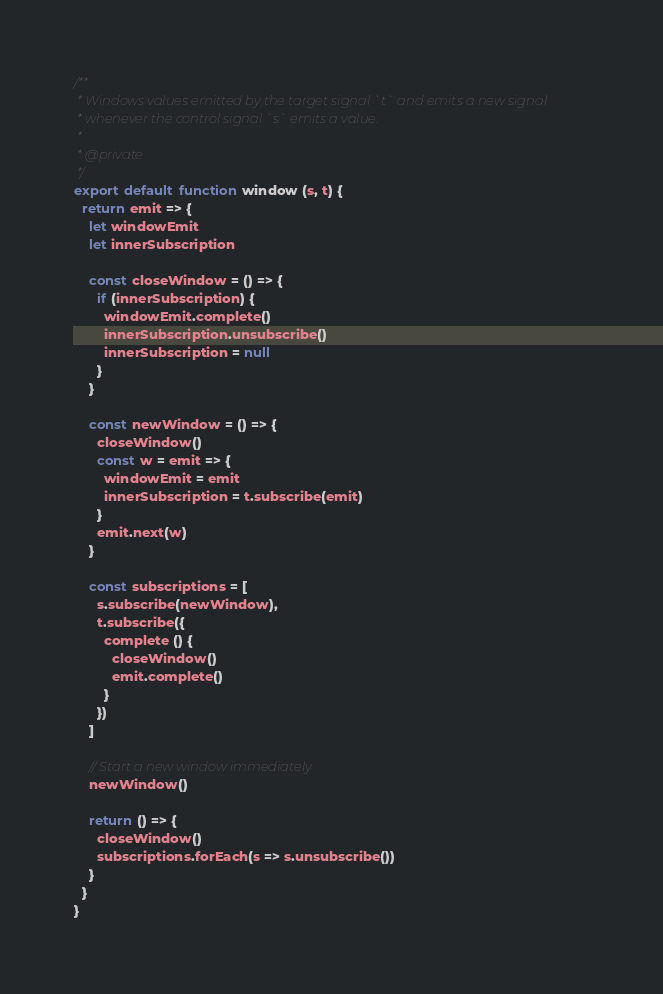Convert code to text. <code><loc_0><loc_0><loc_500><loc_500><_JavaScript_>/**
 * Windows values emitted by the target signal `t` and emits a new signal
 * whenever the control signal `s` emits a value.
 *
 * @private
 */
export default function window (s, t) {
  return emit => {
    let windowEmit
    let innerSubscription

    const closeWindow = () => {
      if (innerSubscription) {
        windowEmit.complete()
        innerSubscription.unsubscribe()
        innerSubscription = null
      }
    }

    const newWindow = () => {
      closeWindow()
      const w = emit => {
        windowEmit = emit
        innerSubscription = t.subscribe(emit)
      }
      emit.next(w)
    }

    const subscriptions = [
      s.subscribe(newWindow),
      t.subscribe({
        complete () {
          closeWindow()
          emit.complete()
        }
      })
    ]

    // Start a new window immediately
    newWindow()

    return () => {
      closeWindow()
      subscriptions.forEach(s => s.unsubscribe())
    }
  }
}
</code> 